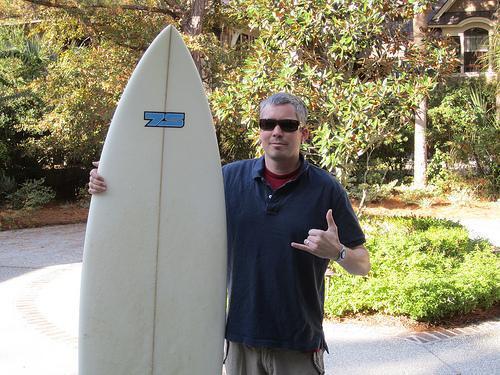How many people are in the image?
Give a very brief answer. 1. 